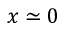<formula> <loc_0><loc_0><loc_500><loc_500>x \simeq 0</formula> 